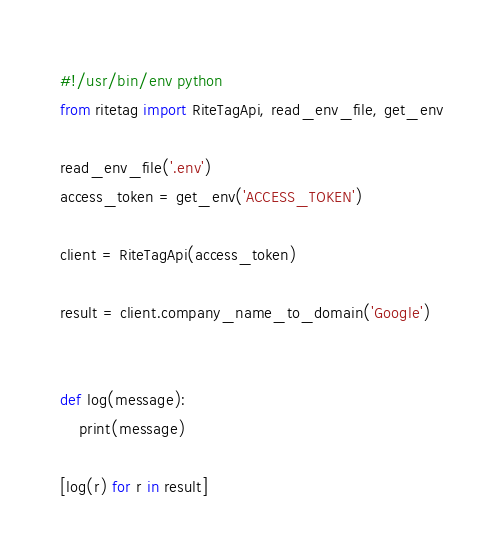Convert code to text. <code><loc_0><loc_0><loc_500><loc_500><_Python_>#!/usr/bin/env python
from ritetag import RiteTagApi, read_env_file, get_env

read_env_file('.env')
access_token = get_env('ACCESS_TOKEN')

client = RiteTagApi(access_token)

result = client.company_name_to_domain('Google')


def log(message):
    print(message)

[log(r) for r in result]
</code> 